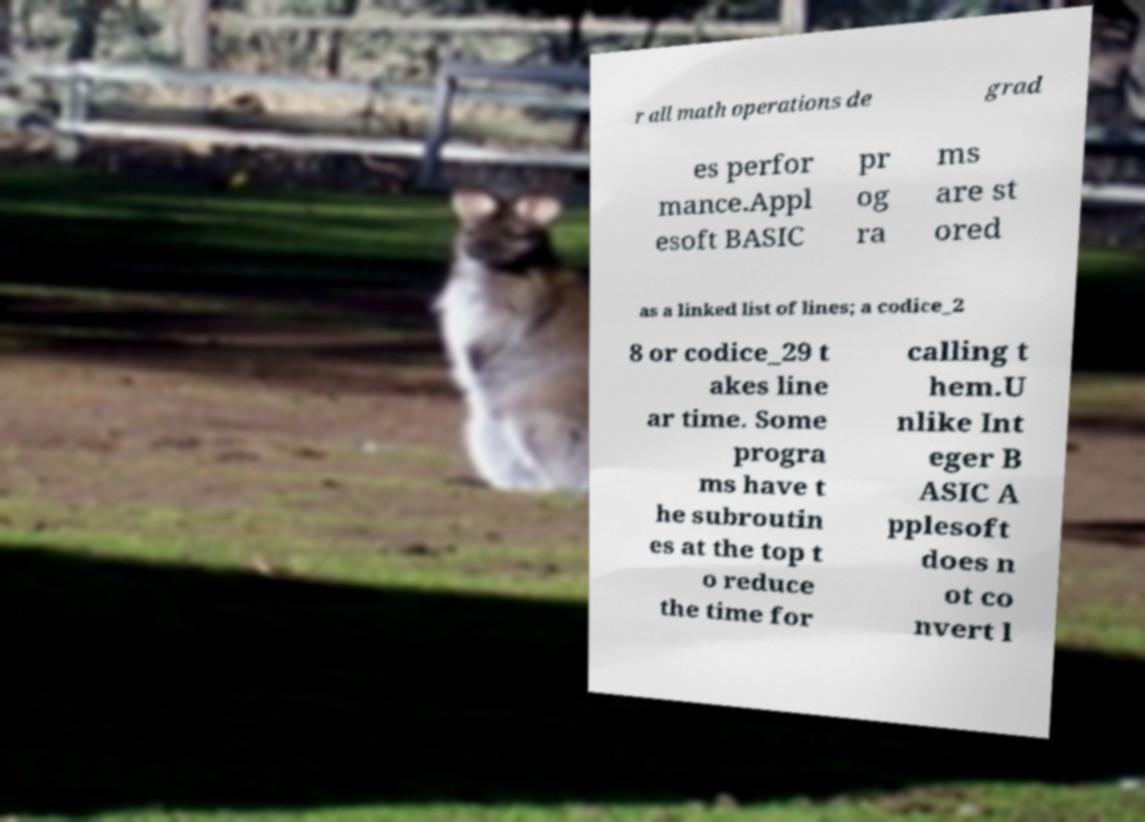I need the written content from this picture converted into text. Can you do that? r all math operations de grad es perfor mance.Appl esoft BASIC pr og ra ms are st ored as a linked list of lines; a codice_2 8 or codice_29 t akes line ar time. Some progra ms have t he subroutin es at the top t o reduce the time for calling t hem.U nlike Int eger B ASIC A pplesoft does n ot co nvert l 